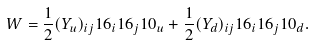Convert formula to latex. <formula><loc_0><loc_0><loc_500><loc_500>W = \frac { 1 } { 2 } ( Y _ { u } ) _ { i j } 1 6 _ { i } 1 6 _ { j } 1 0 _ { u } + \frac { 1 } { 2 } ( Y _ { d } ) _ { i j } 1 6 _ { i } 1 6 _ { j } 1 0 _ { d } .</formula> 